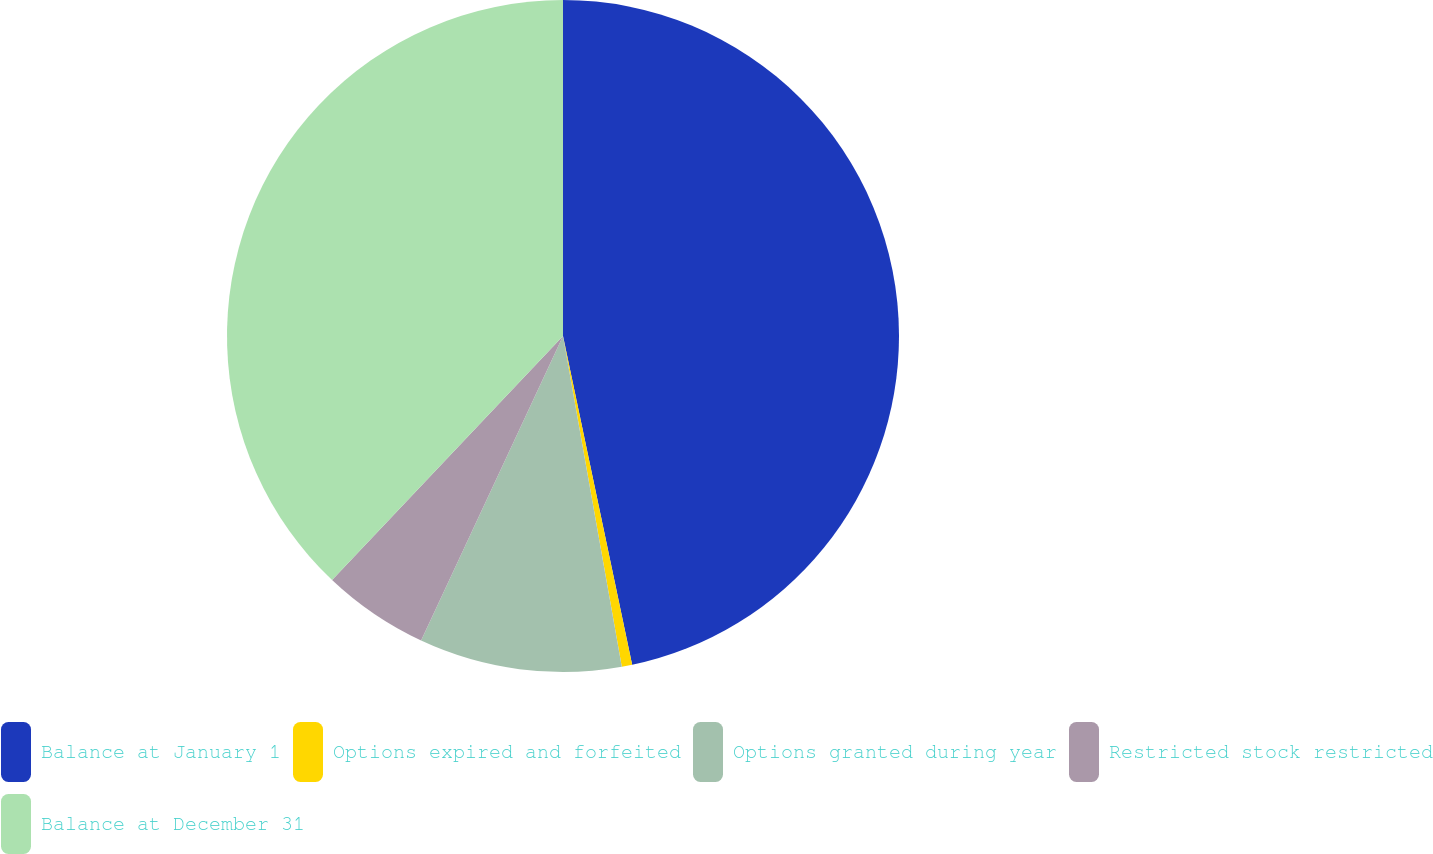Convert chart to OTSL. <chart><loc_0><loc_0><loc_500><loc_500><pie_chart><fcel>Balance at January 1<fcel>Options expired and forfeited<fcel>Options granted during year<fcel>Restricted stock restricted<fcel>Balance at December 31<nl><fcel>46.7%<fcel>0.5%<fcel>9.74%<fcel>5.12%<fcel>37.94%<nl></chart> 